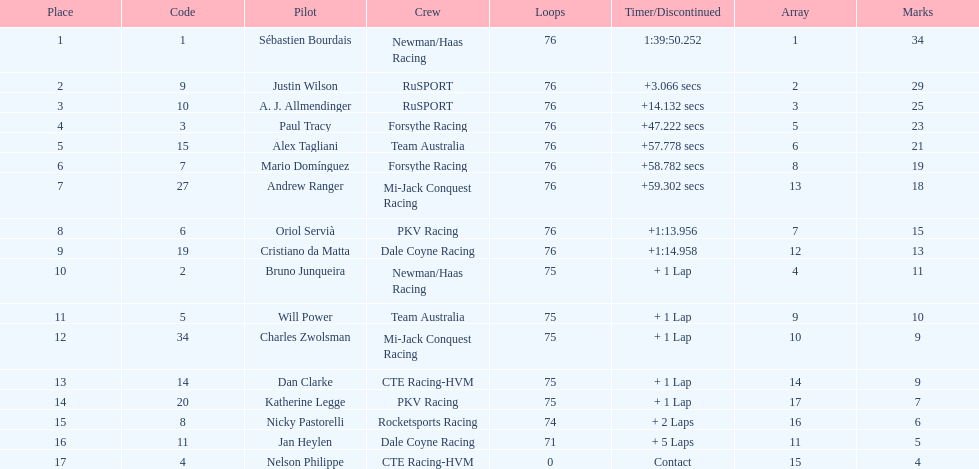What was the total points that canada earned together? 62. 